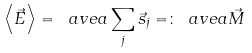<formula> <loc_0><loc_0><loc_500><loc_500>\left \langle \vec { E } \right \rangle = \ a v e { a } \sum _ { j } \vec { s } _ { j } = \colon \ a v e { a } \vec { M }</formula> 